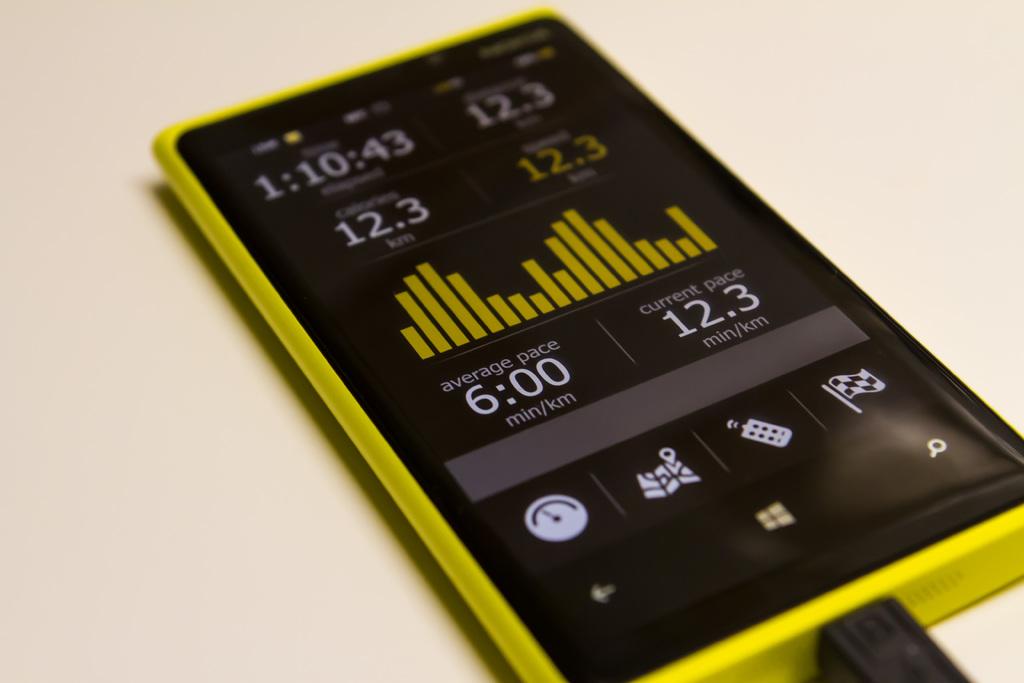What is the average pace?
Keep it short and to the point. 6:00. What is the current pace shown?
Give a very brief answer. 12.3. 